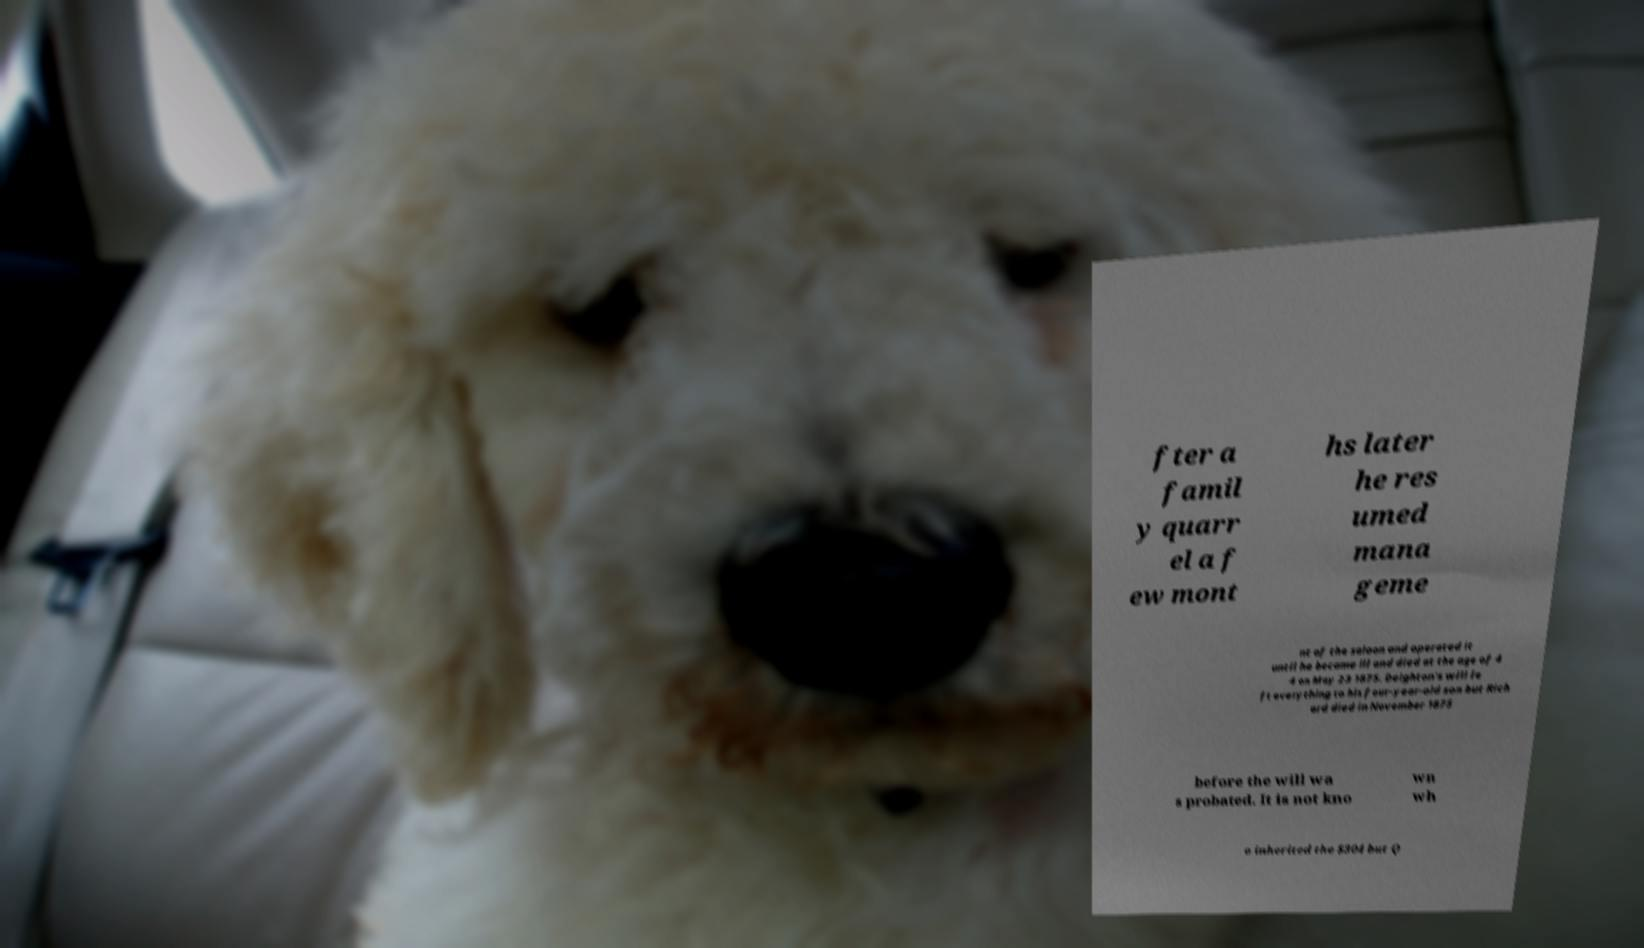Could you assist in decoding the text presented in this image and type it out clearly? fter a famil y quarr el a f ew mont hs later he res umed mana geme nt of the saloon and operated it until he became ill and died at the age of 4 4 on May 23 1875. Deighton's will le ft everything to his four-year-old son but Rich ard died in November 1875 before the will wa s probated. It is not kno wn wh o inherited the $304 but Q 